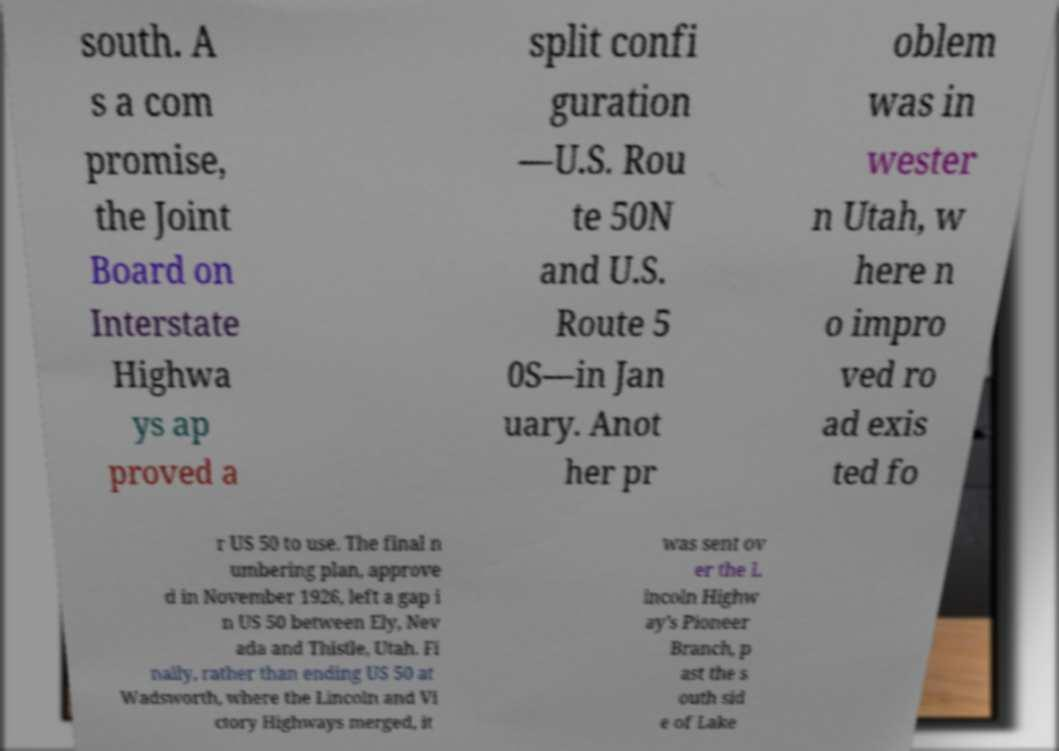Please read and relay the text visible in this image. What does it say? south. A s a com promise, the Joint Board on Interstate Highwa ys ap proved a split confi guration —U.S. Rou te 50N and U.S. Route 5 0S—in Jan uary. Anot her pr oblem was in wester n Utah, w here n o impro ved ro ad exis ted fo r US 50 to use. The final n umbering plan, approve d in November 1926, left a gap i n US 50 between Ely, Nev ada and Thistle, Utah. Fi nally, rather than ending US 50 at Wadsworth, where the Lincoln and Vi ctory Highways merged, it was sent ov er the L incoln Highw ay's Pioneer Branch, p ast the s outh sid e of Lake 